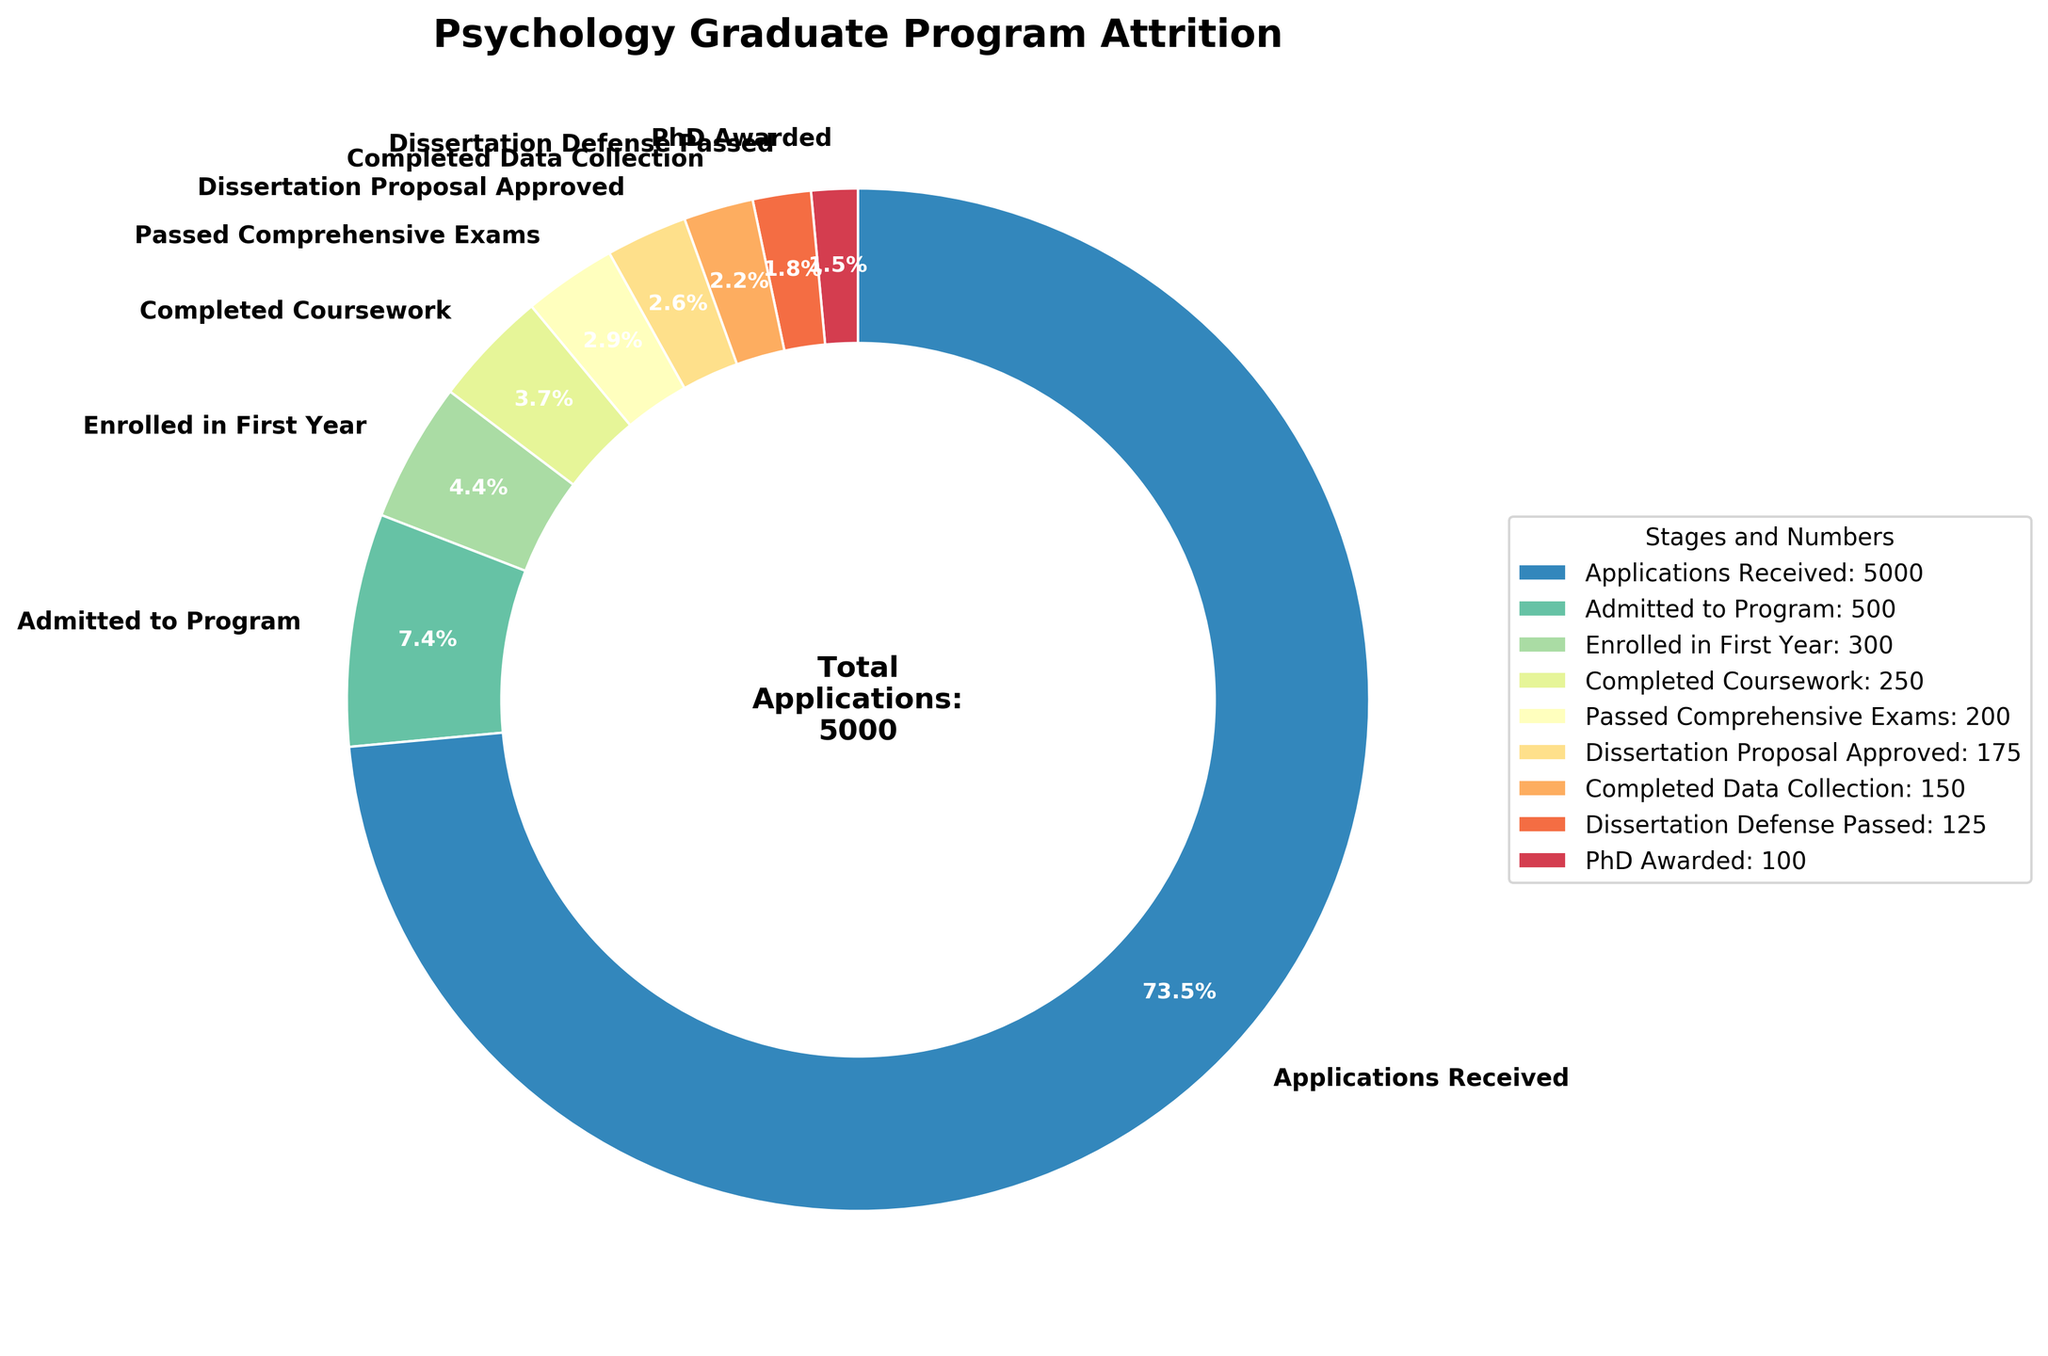What's the total number of students who applied to the psychology graduate program? The figure’s central text indicates the total number of applications received in the program.
Answer: 5000 At which stage do most students drop out between admission and PhD completion? By observing the size of each segment, the most substantial drop occurs between 'Applications Received' (5000) and 'Admitted to Program' (500), reflecting a reduction by 4500 students.
Answer: Applications Received to Admitted to Program What's the percentage of students who get their PhD after being admitted to the program? The chart shows that 100 students out of 500 admitted complete their PhD. The percentage is calculated as (100 / 500) * 100.
Answer: 20% How many more students completed coursework than those who passed the dissertation defense? The number of students who completed coursework (250) minus the number who passed the dissertation defense (125) gives the difference.
Answer: 125 Which stage has the smallest number of students? By examining the figure, the smallest wedge at the end represents the stage "PhD Awarded" with 100 students.
Answer: PhD Awarded What percentage of students who enrolled in the first year eventually receive a PhD? Out of the 300 students who enrolled in the first year, 100 receive a PhD, so the percent is (100 / 300) * 100.
Answer: 33.3% By how much does the number of students drop from ‘Completed Data Collection’ to ‘PhD Awarded’? Subtract the number of students who were awarded PhDs (100) from those who completed data collection (150).
Answer: 50 From the stages provided, which one follows immediately after 'Passed Comprehensive Exams'? The stage order in the chart shows 'Dissertation Proposal Approved' following 'Passed Comprehensive Exams'.
Answer: Dissertation Proposal Approved Which stage sees a decrease of 50 students from the previous one? The stage 'Dissertation Proposal Approved' (175) drops to 'Completed Data Collection' (150), which is a difference of 50 students.
Answer: Dissertation Proposal Approved to Completed Data Collection 